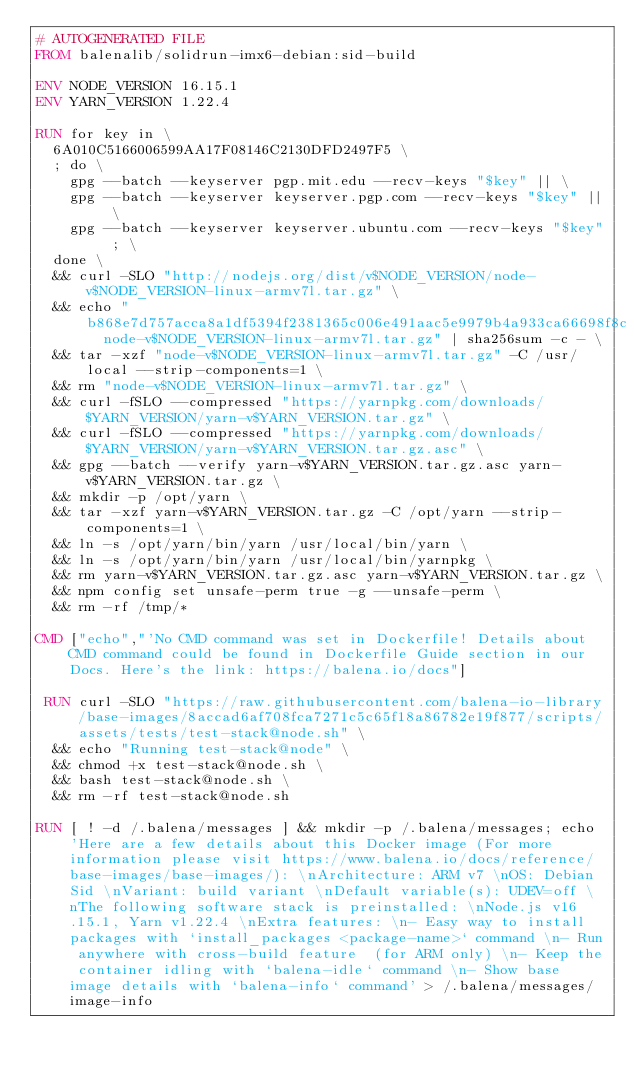<code> <loc_0><loc_0><loc_500><loc_500><_Dockerfile_># AUTOGENERATED FILE
FROM balenalib/solidrun-imx6-debian:sid-build

ENV NODE_VERSION 16.15.1
ENV YARN_VERSION 1.22.4

RUN for key in \
	6A010C5166006599AA17F08146C2130DFD2497F5 \
	; do \
		gpg --batch --keyserver pgp.mit.edu --recv-keys "$key" || \
		gpg --batch --keyserver keyserver.pgp.com --recv-keys "$key" || \
		gpg --batch --keyserver keyserver.ubuntu.com --recv-keys "$key" ; \
	done \
	&& curl -SLO "http://nodejs.org/dist/v$NODE_VERSION/node-v$NODE_VERSION-linux-armv7l.tar.gz" \
	&& echo "b868e7d757acca8a1df5394f2381365c006e491aac5e9979b4a933ca66698f8c  node-v$NODE_VERSION-linux-armv7l.tar.gz" | sha256sum -c - \
	&& tar -xzf "node-v$NODE_VERSION-linux-armv7l.tar.gz" -C /usr/local --strip-components=1 \
	&& rm "node-v$NODE_VERSION-linux-armv7l.tar.gz" \
	&& curl -fSLO --compressed "https://yarnpkg.com/downloads/$YARN_VERSION/yarn-v$YARN_VERSION.tar.gz" \
	&& curl -fSLO --compressed "https://yarnpkg.com/downloads/$YARN_VERSION/yarn-v$YARN_VERSION.tar.gz.asc" \
	&& gpg --batch --verify yarn-v$YARN_VERSION.tar.gz.asc yarn-v$YARN_VERSION.tar.gz \
	&& mkdir -p /opt/yarn \
	&& tar -xzf yarn-v$YARN_VERSION.tar.gz -C /opt/yarn --strip-components=1 \
	&& ln -s /opt/yarn/bin/yarn /usr/local/bin/yarn \
	&& ln -s /opt/yarn/bin/yarn /usr/local/bin/yarnpkg \
	&& rm yarn-v$YARN_VERSION.tar.gz.asc yarn-v$YARN_VERSION.tar.gz \
	&& npm config set unsafe-perm true -g --unsafe-perm \
	&& rm -rf /tmp/*

CMD ["echo","'No CMD command was set in Dockerfile! Details about CMD command could be found in Dockerfile Guide section in our Docs. Here's the link: https://balena.io/docs"]

 RUN curl -SLO "https://raw.githubusercontent.com/balena-io-library/base-images/8accad6af708fca7271c5c65f18a86782e19f877/scripts/assets/tests/test-stack@node.sh" \
  && echo "Running test-stack@node" \
  && chmod +x test-stack@node.sh \
  && bash test-stack@node.sh \
  && rm -rf test-stack@node.sh 

RUN [ ! -d /.balena/messages ] && mkdir -p /.balena/messages; echo 'Here are a few details about this Docker image (For more information please visit https://www.balena.io/docs/reference/base-images/base-images/): \nArchitecture: ARM v7 \nOS: Debian Sid \nVariant: build variant \nDefault variable(s): UDEV=off \nThe following software stack is preinstalled: \nNode.js v16.15.1, Yarn v1.22.4 \nExtra features: \n- Easy way to install packages with `install_packages <package-name>` command \n- Run anywhere with cross-build feature  (for ARM only) \n- Keep the container idling with `balena-idle` command \n- Show base image details with `balena-info` command' > /.balena/messages/image-info</code> 